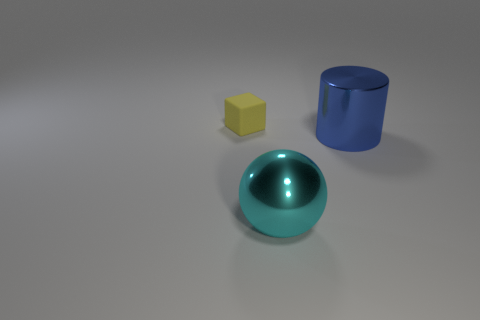There is a metal object to the right of the big thing to the left of the blue shiny thing; how many shiny cylinders are behind it?
Provide a succinct answer. 0. How many things are left of the large cyan shiny sphere and to the right of the yellow matte block?
Keep it short and to the point. 0. Is there anything else that is made of the same material as the cyan sphere?
Provide a succinct answer. Yes. Is the big blue cylinder made of the same material as the large cyan object?
Make the answer very short. Yes. What shape is the thing behind the big thing that is behind the shiny object that is to the left of the large blue cylinder?
Your answer should be very brief. Cube. Are there fewer large metallic objects left of the cylinder than things behind the shiny ball?
Keep it short and to the point. Yes. The yellow object to the left of the big metal thing on the right side of the big cyan metal ball is what shape?
Offer a terse response. Cube. What number of blue objects are small rubber blocks or large shiny objects?
Provide a short and direct response. 1. Are there fewer cyan shiny balls behind the large blue shiny cylinder than large yellow rubber objects?
Offer a terse response. No. How many objects are on the left side of the large thing left of the blue cylinder?
Your response must be concise. 1. 